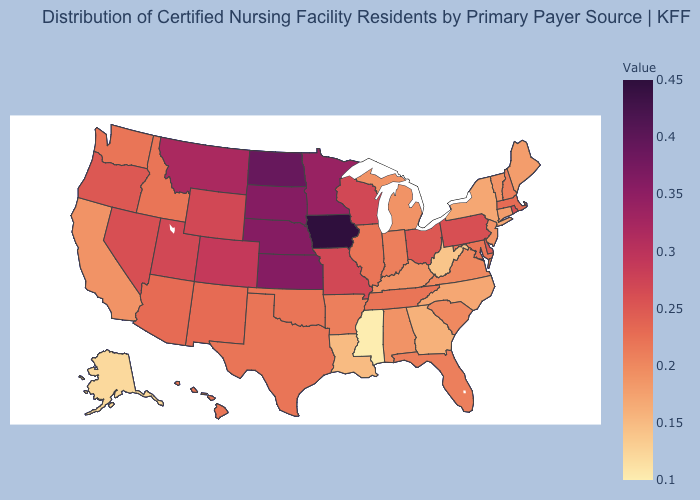Does New York have the lowest value in the Northeast?
Short answer required. Yes. Does Hawaii have a lower value than Alaska?
Concise answer only. No. Which states have the highest value in the USA?
Be succinct. Iowa. 